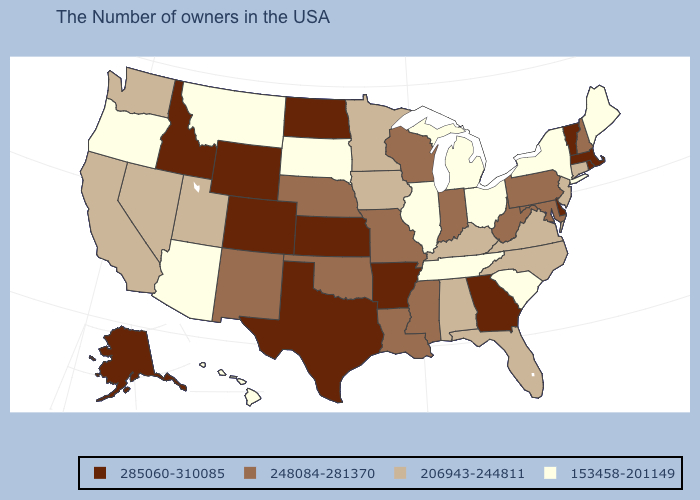Name the states that have a value in the range 153458-201149?
Be succinct. Maine, New York, South Carolina, Ohio, Michigan, Tennessee, Illinois, South Dakota, Montana, Arizona, Oregon, Hawaii. Is the legend a continuous bar?
Answer briefly. No. Which states hav the highest value in the West?
Give a very brief answer. Wyoming, Colorado, Idaho, Alaska. Name the states that have a value in the range 285060-310085?
Quick response, please. Massachusetts, Rhode Island, Vermont, Delaware, Georgia, Arkansas, Kansas, Texas, North Dakota, Wyoming, Colorado, Idaho, Alaska. Which states have the lowest value in the MidWest?
Write a very short answer. Ohio, Michigan, Illinois, South Dakota. What is the value of Texas?
Quick response, please. 285060-310085. What is the lowest value in the Northeast?
Give a very brief answer. 153458-201149. Which states have the lowest value in the South?
Quick response, please. South Carolina, Tennessee. Among the states that border Virginia , which have the lowest value?
Concise answer only. Tennessee. What is the value of Delaware?
Concise answer only. 285060-310085. What is the lowest value in states that border Minnesota?
Write a very short answer. 153458-201149. What is the value of North Carolina?
Be succinct. 206943-244811. Among the states that border Idaho , which have the lowest value?
Be succinct. Montana, Oregon. What is the value of California?
Be succinct. 206943-244811. Does the map have missing data?
Be succinct. No. 